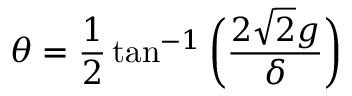<formula> <loc_0><loc_0><loc_500><loc_500>\theta = \frac { 1 } { 2 } \tan ^ { - 1 } \left ( \frac { 2 \sqrt { 2 } g } { \delta } \right )</formula> 